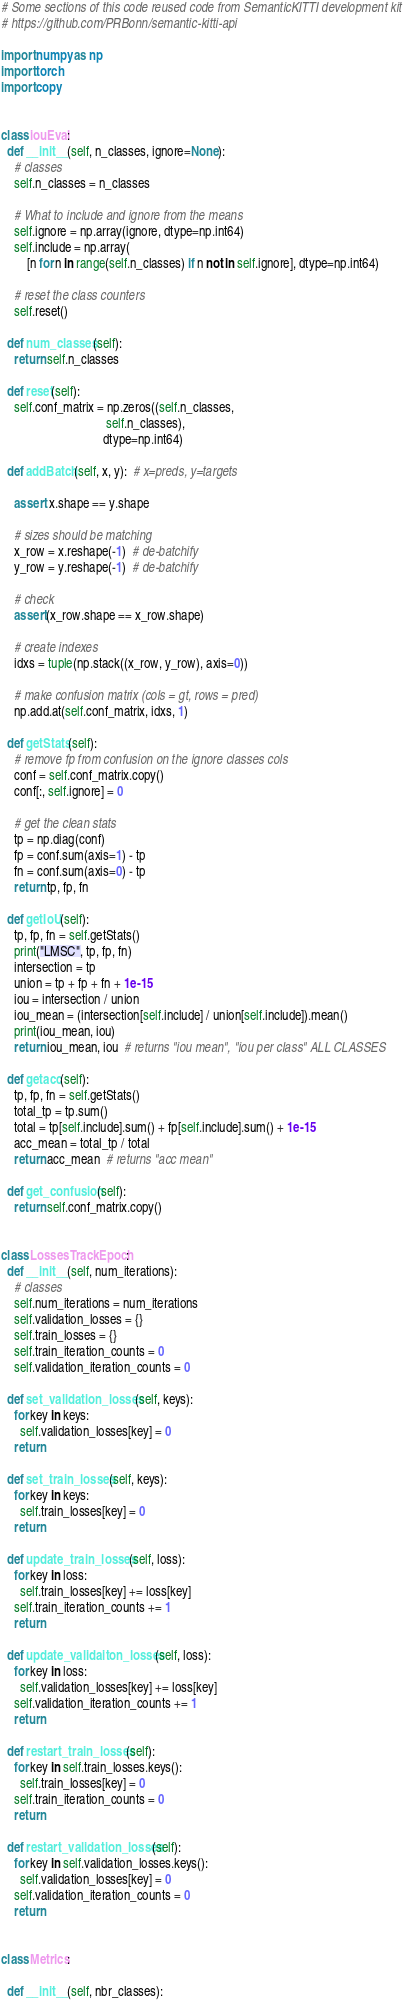<code> <loc_0><loc_0><loc_500><loc_500><_Python_># Some sections of this code reused code from SemanticKITTI development kit
# https://github.com/PRBonn/semantic-kitti-api

import numpy as np
import torch
import copy


class iouEval:
  def __init__(self, n_classes, ignore=None):
    # classes
    self.n_classes = n_classes

    # What to include and ignore from the means
    self.ignore = np.array(ignore, dtype=np.int64)
    self.include = np.array(
        [n for n in range(self.n_classes) if n not in self.ignore], dtype=np.int64)

    # reset the class counters
    self.reset()

  def num_classes(self):
    return self.n_classes

  def reset(self):
    self.conf_matrix = np.zeros((self.n_classes,
                                 self.n_classes),
                                dtype=np.int64)

  def addBatch(self, x, y):  # x=preds, y=targets

    assert x.shape == y.shape

    # sizes should be matching
    x_row = x.reshape(-1)  # de-batchify
    y_row = y.reshape(-1)  # de-batchify

    # check
    assert(x_row.shape == x_row.shape)

    # create indexes
    idxs = tuple(np.stack((x_row, y_row), axis=0))

    # make confusion matrix (cols = gt, rows = pred)
    np.add.at(self.conf_matrix, idxs, 1)

  def getStats(self):
    # remove fp from confusion on the ignore classes cols
    conf = self.conf_matrix.copy()
    conf[:, self.ignore] = 0

    # get the clean stats
    tp = np.diag(conf)
    fp = conf.sum(axis=1) - tp
    fn = conf.sum(axis=0) - tp
    return tp, fp, fn

  def getIoU(self):
    tp, fp, fn = self.getStats()
    print("LMSC", tp, fp, fn)
    intersection = tp
    union = tp + fp + fn + 1e-15
    iou = intersection / union
    iou_mean = (intersection[self.include] / union[self.include]).mean()
    print(iou_mean, iou)
    return iou_mean, iou  # returns "iou mean", "iou per class" ALL CLASSES

  def getacc(self):
    tp, fp, fn = self.getStats()
    total_tp = tp.sum()
    total = tp[self.include].sum() + fp[self.include].sum() + 1e-15
    acc_mean = total_tp / total
    return acc_mean  # returns "acc mean"

  def get_confusion(self):
    return self.conf_matrix.copy()


class LossesTrackEpoch:
  def __init__(self, num_iterations):
    # classes
    self.num_iterations = num_iterations
    self.validation_losses = {}
    self.train_losses = {}
    self.train_iteration_counts = 0
    self.validation_iteration_counts = 0

  def set_validation_losses(self, keys):
    for key in keys:
      self.validation_losses[key] = 0
    return

  def set_train_losses(self, keys):
    for key in keys:
      self.train_losses[key] = 0
    return

  def update_train_losses(self, loss):
    for key in loss:
      self.train_losses[key] += loss[key]
    self.train_iteration_counts += 1
    return

  def update_validaiton_losses(self, loss):
    for key in loss:
      self.validation_losses[key] += loss[key]
    self.validation_iteration_counts += 1
    return

  def restart_train_losses(self):
    for key in self.train_losses.keys():
      self.train_losses[key] = 0
    self.train_iteration_counts = 0
    return

  def restart_validation_losses(self):
    for key in self.validation_losses.keys():
      self.validation_losses[key] = 0
    self.validation_iteration_counts = 0
    return


class Metrics:

  def __init__(self, nbr_classes):
</code> 